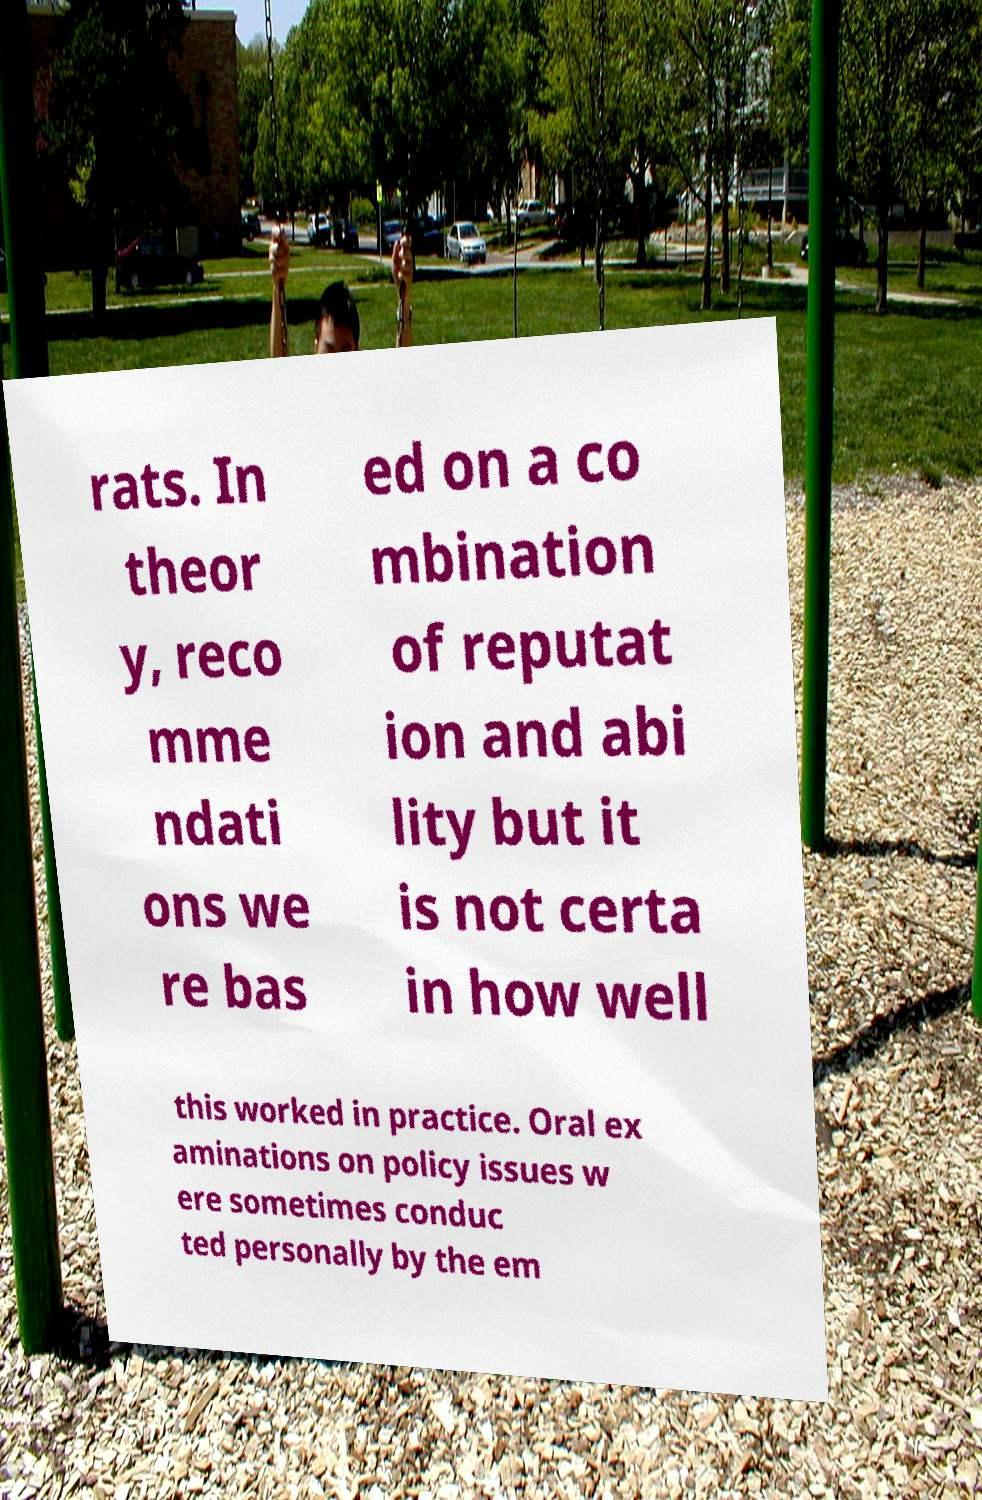What messages or text are displayed in this image? I need them in a readable, typed format. rats. In theor y, reco mme ndati ons we re bas ed on a co mbination of reputat ion and abi lity but it is not certa in how well this worked in practice. Oral ex aminations on policy issues w ere sometimes conduc ted personally by the em 